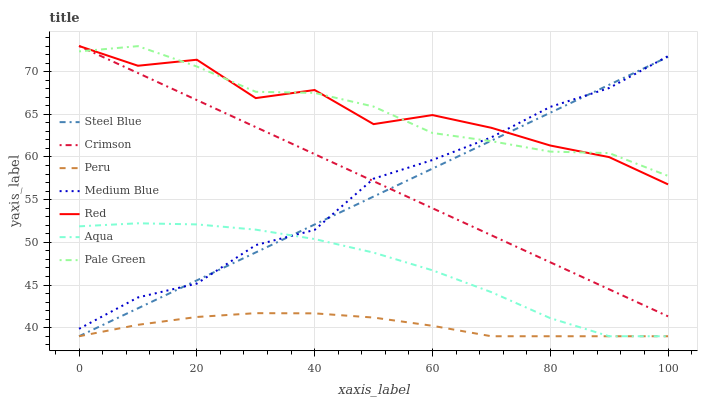Does Aqua have the minimum area under the curve?
Answer yes or no. No. Does Aqua have the maximum area under the curve?
Answer yes or no. No. Is Aqua the smoothest?
Answer yes or no. No. Is Aqua the roughest?
Answer yes or no. No. Does Pale Green have the lowest value?
Answer yes or no. No. Does Aqua have the highest value?
Answer yes or no. No. Is Peru less than Medium Blue?
Answer yes or no. Yes. Is Pale Green greater than Aqua?
Answer yes or no. Yes. Does Peru intersect Medium Blue?
Answer yes or no. No. 